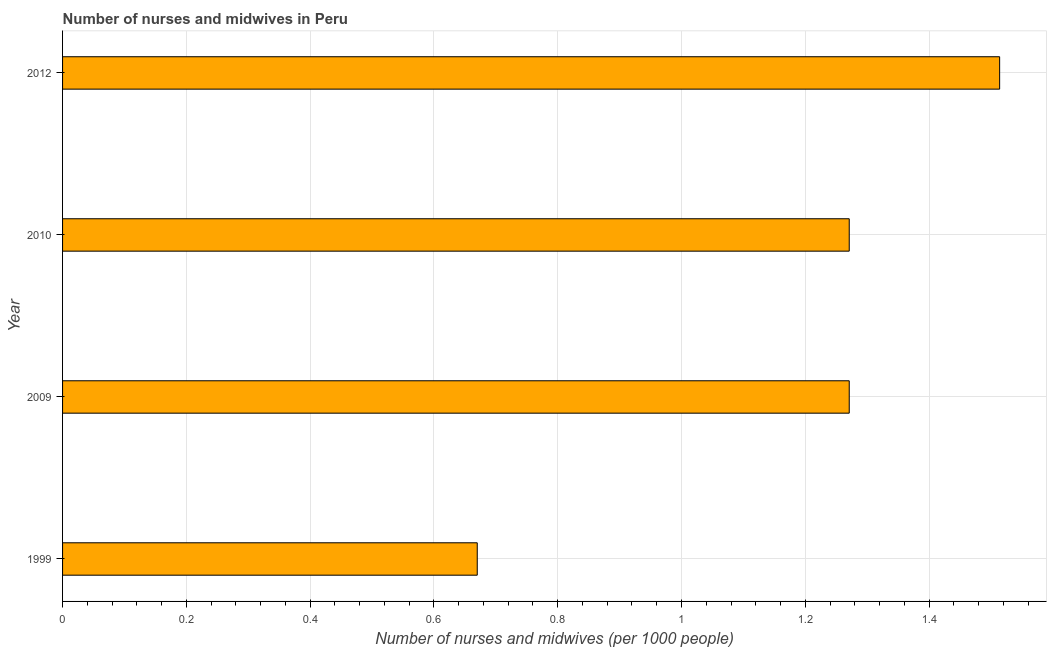What is the title of the graph?
Make the answer very short. Number of nurses and midwives in Peru. What is the label or title of the X-axis?
Provide a short and direct response. Number of nurses and midwives (per 1000 people). What is the label or title of the Y-axis?
Keep it short and to the point. Year. What is the number of nurses and midwives in 2010?
Ensure brevity in your answer.  1.27. Across all years, what is the maximum number of nurses and midwives?
Ensure brevity in your answer.  1.51. Across all years, what is the minimum number of nurses and midwives?
Ensure brevity in your answer.  0.67. In which year was the number of nurses and midwives maximum?
Give a very brief answer. 2012. What is the sum of the number of nurses and midwives?
Provide a short and direct response. 4.73. What is the difference between the number of nurses and midwives in 1999 and 2009?
Offer a terse response. -0.6. What is the average number of nurses and midwives per year?
Keep it short and to the point. 1.18. What is the median number of nurses and midwives?
Make the answer very short. 1.27. In how many years, is the number of nurses and midwives greater than 1.04 ?
Your answer should be very brief. 3. Do a majority of the years between 1999 and 2012 (inclusive) have number of nurses and midwives greater than 0.52 ?
Keep it short and to the point. Yes. What is the ratio of the number of nurses and midwives in 1999 to that in 2010?
Your answer should be compact. 0.53. Is the number of nurses and midwives in 1999 less than that in 2010?
Provide a succinct answer. Yes. What is the difference between the highest and the second highest number of nurses and midwives?
Offer a very short reply. 0.24. Is the sum of the number of nurses and midwives in 2009 and 2012 greater than the maximum number of nurses and midwives across all years?
Your answer should be compact. Yes. What is the difference between the highest and the lowest number of nurses and midwives?
Your answer should be compact. 0.84. How many bars are there?
Offer a terse response. 4. What is the difference between two consecutive major ticks on the X-axis?
Provide a short and direct response. 0.2. What is the Number of nurses and midwives (per 1000 people) of 1999?
Give a very brief answer. 0.67. What is the Number of nurses and midwives (per 1000 people) in 2009?
Provide a succinct answer. 1.27. What is the Number of nurses and midwives (per 1000 people) in 2010?
Your answer should be very brief. 1.27. What is the Number of nurses and midwives (per 1000 people) in 2012?
Your answer should be very brief. 1.51. What is the difference between the Number of nurses and midwives (per 1000 people) in 1999 and 2009?
Ensure brevity in your answer.  -0.6. What is the difference between the Number of nurses and midwives (per 1000 people) in 1999 and 2010?
Your answer should be compact. -0.6. What is the difference between the Number of nurses and midwives (per 1000 people) in 1999 and 2012?
Provide a succinct answer. -0.84. What is the difference between the Number of nurses and midwives (per 1000 people) in 2009 and 2010?
Ensure brevity in your answer.  0. What is the difference between the Number of nurses and midwives (per 1000 people) in 2009 and 2012?
Give a very brief answer. -0.24. What is the difference between the Number of nurses and midwives (per 1000 people) in 2010 and 2012?
Ensure brevity in your answer.  -0.24. What is the ratio of the Number of nurses and midwives (per 1000 people) in 1999 to that in 2009?
Your answer should be very brief. 0.53. What is the ratio of the Number of nurses and midwives (per 1000 people) in 1999 to that in 2010?
Keep it short and to the point. 0.53. What is the ratio of the Number of nurses and midwives (per 1000 people) in 1999 to that in 2012?
Your response must be concise. 0.44. What is the ratio of the Number of nurses and midwives (per 1000 people) in 2009 to that in 2010?
Give a very brief answer. 1. What is the ratio of the Number of nurses and midwives (per 1000 people) in 2009 to that in 2012?
Make the answer very short. 0.84. What is the ratio of the Number of nurses and midwives (per 1000 people) in 2010 to that in 2012?
Your answer should be compact. 0.84. 